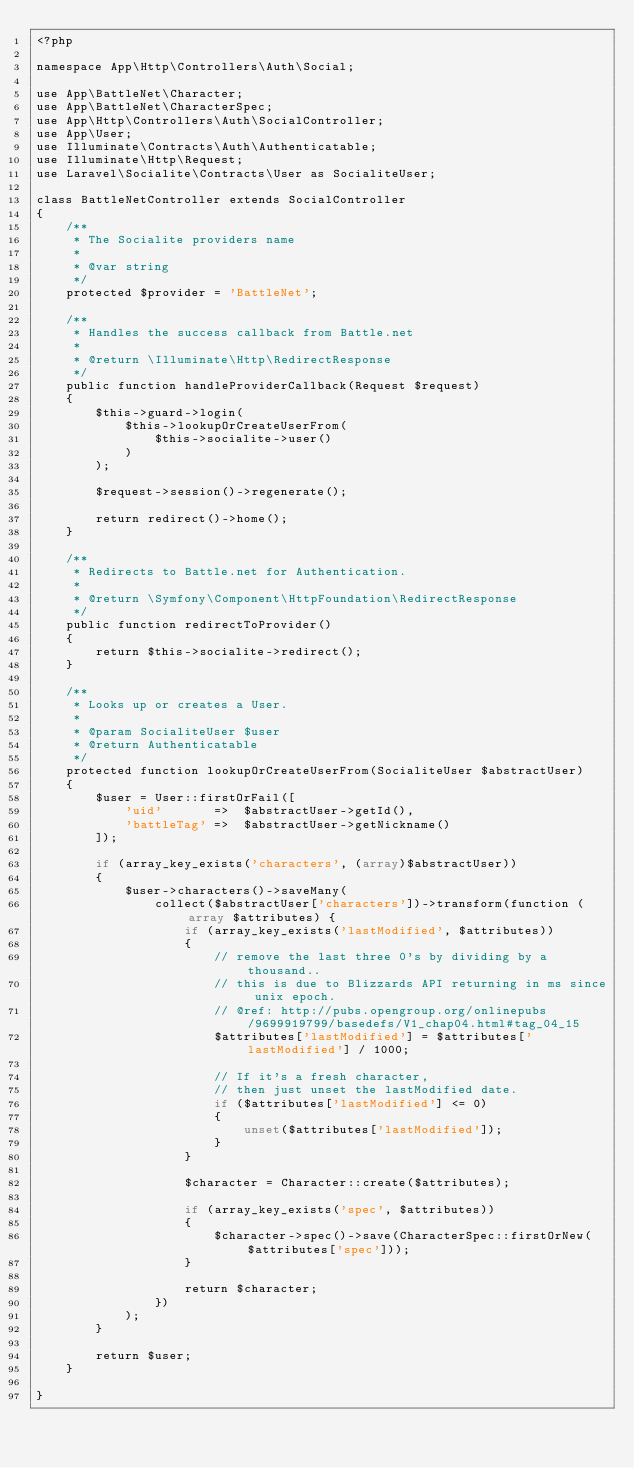Convert code to text. <code><loc_0><loc_0><loc_500><loc_500><_PHP_><?php

namespace App\Http\Controllers\Auth\Social;

use App\BattleNet\Character;
use App\BattleNet\CharacterSpec;
use App\Http\Controllers\Auth\SocialController;
use App\User;
use Illuminate\Contracts\Auth\Authenticatable;
use Illuminate\Http\Request;
use Laravel\Socialite\Contracts\User as SocialiteUser;

class BattleNetController extends SocialController
{
    /**
     * The Socialite providers name
     *
     * @var string
     */
    protected $provider = 'BattleNet';

    /**
     * Handles the success callback from Battle.net
     *
     * @return \Illuminate\Http\RedirectResponse
     */
    public function handleProviderCallback(Request $request)
    {
        $this->guard->login(
            $this->lookupOrCreateUserFrom(
                $this->socialite->user()
            )
        );

        $request->session()->regenerate();

        return redirect()->home();
    }

    /**
     * Redirects to Battle.net for Authentication.
     *
     * @return \Symfony\Component\HttpFoundation\RedirectResponse
     */
    public function redirectToProvider()
    {
        return $this->socialite->redirect();
    }

    /**
     * Looks up or creates a User.
     *
     * @param SocialiteUser $user
     * @return Authenticatable
     */
    protected function lookupOrCreateUserFrom(SocialiteUser $abstractUser)
    {
        $user = User::firstOrFail([
            'uid'       =>  $abstractUser->getId(),
            'battleTag' =>  $abstractUser->getNickname()
        ]);

        if (array_key_exists('characters', (array)$abstractUser))
        {
            $user->characters()->saveMany(
                collect($abstractUser['characters'])->transform(function (array $attributes) {
                    if (array_key_exists('lastModified', $attributes))
                    {
                        // remove the last three 0's by dividing by a thousand..
                        // this is due to Blizzards API returning in ms since unix epoch.
                        // @ref: http://pubs.opengroup.org/onlinepubs/9699919799/basedefs/V1_chap04.html#tag_04_15
                        $attributes['lastModified'] = $attributes['lastModified'] / 1000;

                        // If it's a fresh character,
                        // then just unset the lastModified date.
                        if ($attributes['lastModified'] <= 0)
                        {
                            unset($attributes['lastModified']);
                        }
                    }

                    $character = Character::create($attributes);

                    if (array_key_exists('spec', $attributes))
                    {
                        $character->spec()->save(CharacterSpec::firstOrNew($attributes['spec']));
                    }

                    return $character;
                })
            );
        }

        return $user;
    }

}
</code> 